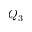<formula> <loc_0><loc_0><loc_500><loc_500>Q _ { 3 }</formula> 